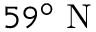Convert formula to latex. <formula><loc_0><loc_0><loc_500><loc_500>5 9 ^ { \circ } N</formula> 